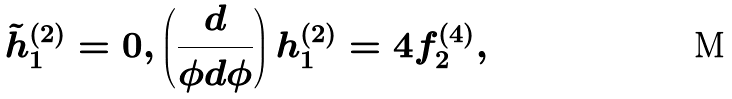<formula> <loc_0><loc_0><loc_500><loc_500>\tilde { h } ^ { ( 2 ) } _ { 1 } = 0 , \left ( \frac { d } { \phi d \phi } \right ) h ^ { ( 2 ) } _ { 1 } = 4 f ^ { ( 4 ) } _ { 2 } ,</formula> 